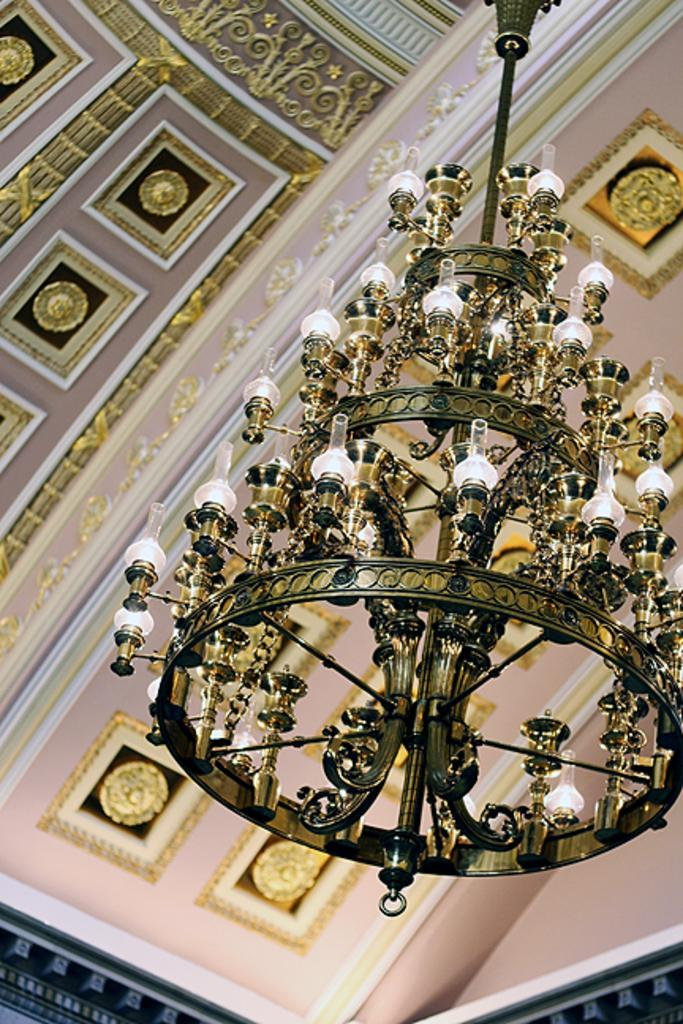What is there is a chandelier in the image, where is it located? The chandelier is hanging from the rooftop in the image. What can be seen on the roof in the image? There are designs on the roof in the image. What type of advertisement can be seen on the chandelier in the image? There is no advertisement present on the chandelier in the image. 